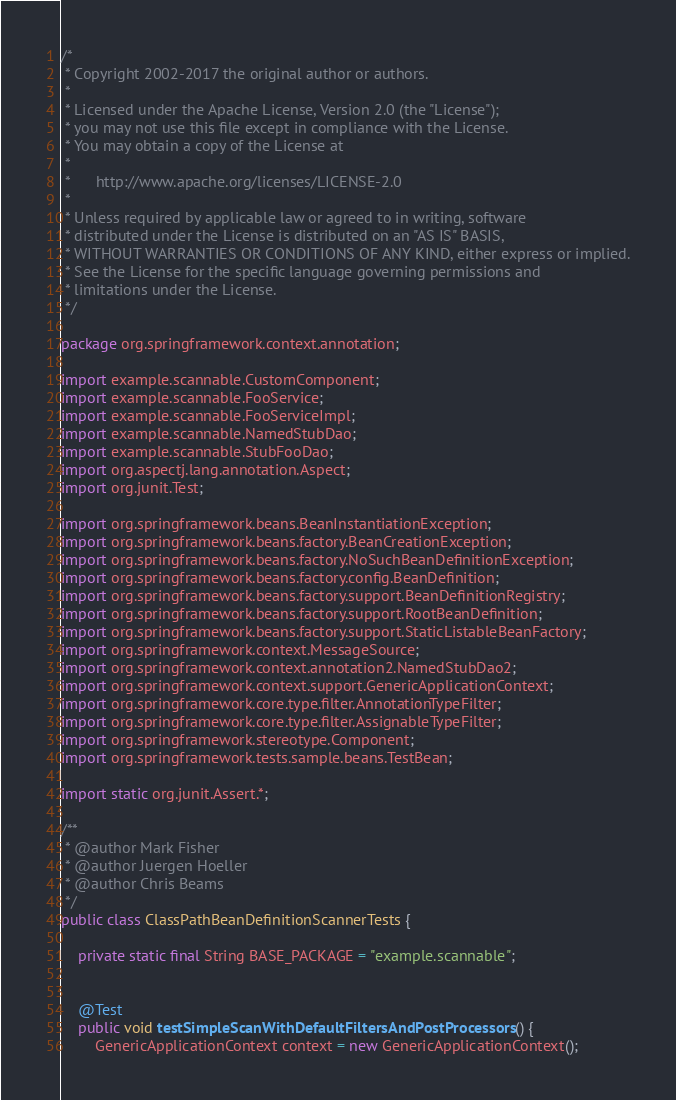Convert code to text. <code><loc_0><loc_0><loc_500><loc_500><_Java_>/*
 * Copyright 2002-2017 the original author or authors.
 *
 * Licensed under the Apache License, Version 2.0 (the "License");
 * you may not use this file except in compliance with the License.
 * You may obtain a copy of the License at
 *
 *      http://www.apache.org/licenses/LICENSE-2.0
 *
 * Unless required by applicable law or agreed to in writing, software
 * distributed under the License is distributed on an "AS IS" BASIS,
 * WITHOUT WARRANTIES OR CONDITIONS OF ANY KIND, either express or implied.
 * See the License for the specific language governing permissions and
 * limitations under the License.
 */

package org.springframework.context.annotation;

import example.scannable.CustomComponent;
import example.scannable.FooService;
import example.scannable.FooServiceImpl;
import example.scannable.NamedStubDao;
import example.scannable.StubFooDao;
import org.aspectj.lang.annotation.Aspect;
import org.junit.Test;

import org.springframework.beans.BeanInstantiationException;
import org.springframework.beans.factory.BeanCreationException;
import org.springframework.beans.factory.NoSuchBeanDefinitionException;
import org.springframework.beans.factory.config.BeanDefinition;
import org.springframework.beans.factory.support.BeanDefinitionRegistry;
import org.springframework.beans.factory.support.RootBeanDefinition;
import org.springframework.beans.factory.support.StaticListableBeanFactory;
import org.springframework.context.MessageSource;
import org.springframework.context.annotation2.NamedStubDao2;
import org.springframework.context.support.GenericApplicationContext;
import org.springframework.core.type.filter.AnnotationTypeFilter;
import org.springframework.core.type.filter.AssignableTypeFilter;
import org.springframework.stereotype.Component;
import org.springframework.tests.sample.beans.TestBean;

import static org.junit.Assert.*;

/**
 * @author Mark Fisher
 * @author Juergen Hoeller
 * @author Chris Beams
 */
public class ClassPathBeanDefinitionScannerTests {

	private static final String BASE_PACKAGE = "example.scannable";


	@Test
	public void testSimpleScanWithDefaultFiltersAndPostProcessors() {
		GenericApplicationContext context = new GenericApplicationContext();</code> 